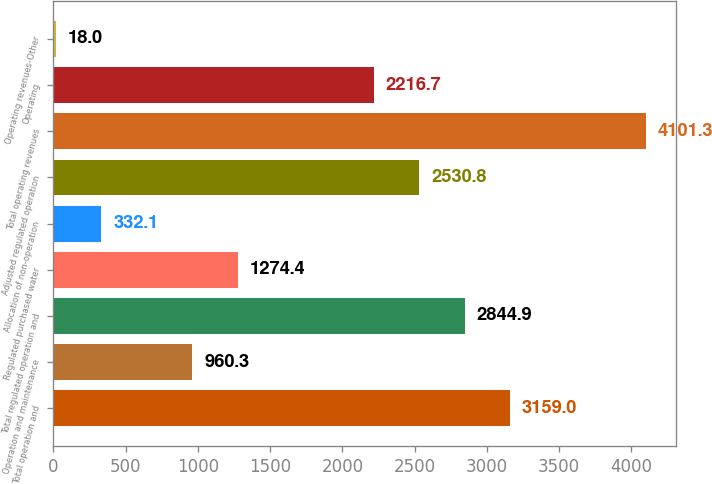Convert chart. <chart><loc_0><loc_0><loc_500><loc_500><bar_chart><fcel>Total operation and<fcel>Operation and maintenance<fcel>Total regulated operation and<fcel>Regulated purchased water<fcel>Allocation of non-operation<fcel>Adjusted regulated operation<fcel>Total operating revenues<fcel>Operating<fcel>Operating revenues-Other<nl><fcel>3159<fcel>960.3<fcel>2844.9<fcel>1274.4<fcel>332.1<fcel>2530.8<fcel>4101.3<fcel>2216.7<fcel>18<nl></chart> 